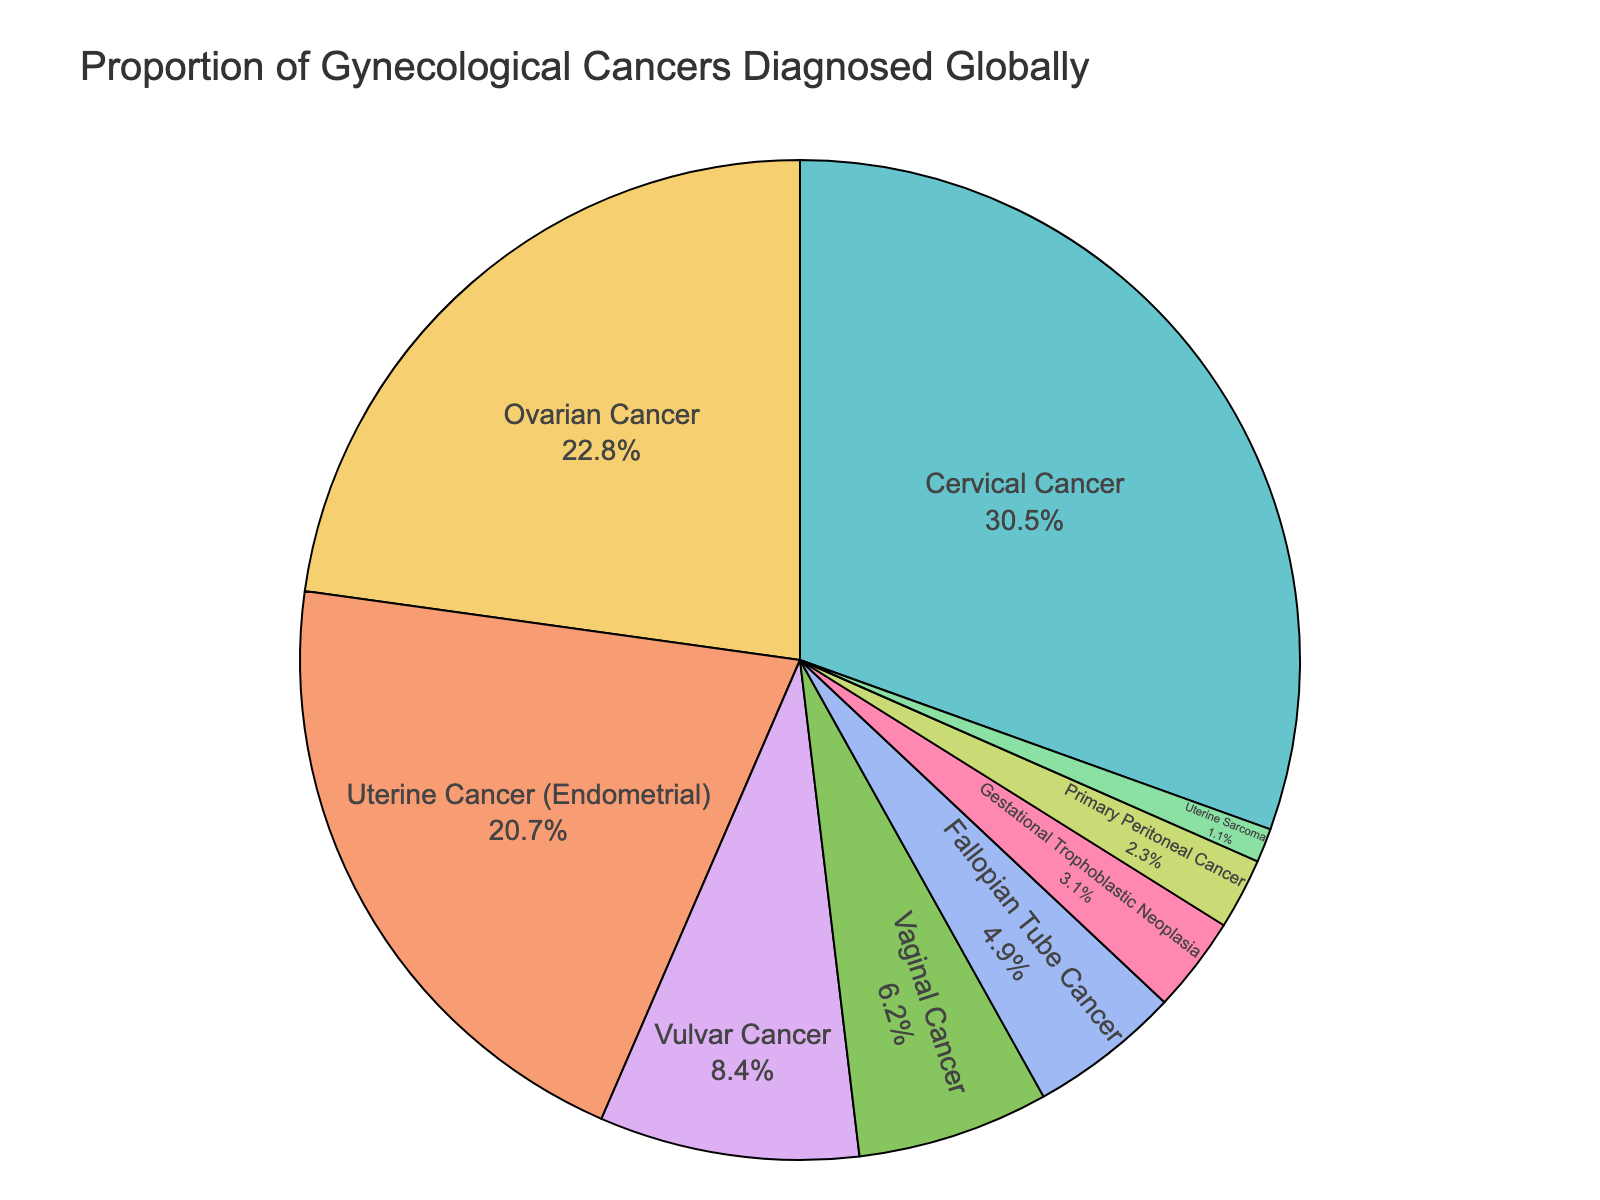What is the most common type of gynecological cancer diagnosed globally? To find the most common type of gynecological cancer diagnosed globally, we look for the cancer type with the largest segment in the pie chart. The pie chart shows that "Cervical Cancer" takes up the largest portion at 30.5%.
Answer: Cervical Cancer Which two types of gynecological cancers together account for over 50% of diagnoses? To determine which two types together account for over 50%, we sum the two highest values in the pie chart. Cervical Cancer (30.5%) and Ovarian Cancer (22.8%) add up to 53.3%.
Answer: Cervical Cancer and Ovarian Cancer How many cancer types have a percentage below 5%? Check the pie chart for cancer types with segments smaller than 5%. Fallopian Tube Cancer (4.9%), Gestational Trophoblastic Neoplasia (3.1%), Primary Peritoneal Cancer (2.3%), and Uterine Sarcoma (1.1%) are those types.
Answer: Four Is Ovarian Cancer more common than Uterine Cancer (Endometrial)? Compare the percentages of Ovarian Cancer and Uterine Cancer (Endometrial) in the pie chart. Ovarian Cancer has 22.8%, and Uterine Cancer (Endometrial) has 20.7%, so Ovarian Cancer is more common.
Answer: Yes Which cancer type has the smallest proportion? Look for the smallest segment in the pie chart. Uterine Sarcoma, at 1.1%, is the smallest.
Answer: Uterine Sarcoma What is the combined percentage of Vulvar Cancer and Vaginal Cancer? Add the proportions of Vulvar Cancer (8.4%) and Vaginal Cancer (6.2%). The sum is 8.4% + 6.2% = 14.6%.
Answer: 14.6% How many types of gynecological cancers make up more than 20% of the diagnoses each? Identify the segments with percentages greater than 20%. Cervical Cancer (30.5%), Ovarian Cancer (22.8%), and Uterine Cancer (Endometrial) (20.7%) are the ones.
Answer: Three Are there more types of cancers below 10% or above 10% in the chart? Count the types below 10%: Vulvar Cancer, Vaginal Cancer, Fallopian Tube Cancer, Gestational Trophoblastic Neoplasia, Primary Peritoneal Cancer, Uterine Sarcoma (6 types). Above 10%: Cervical Cancer, Ovarian Cancer, Uterine Cancer (3 types). There are more types below 10%.
Answer: Below 10% What is the difference in the percentage points between the most common and the least common cancer types? Subtract the percentage of the least common (Uterine Sarcoma, 1.1%) from the most common (Cervical Cancer, 30.5%) which is 30.5% - 1.1% = 29.4%.
Answer: 29.4% 